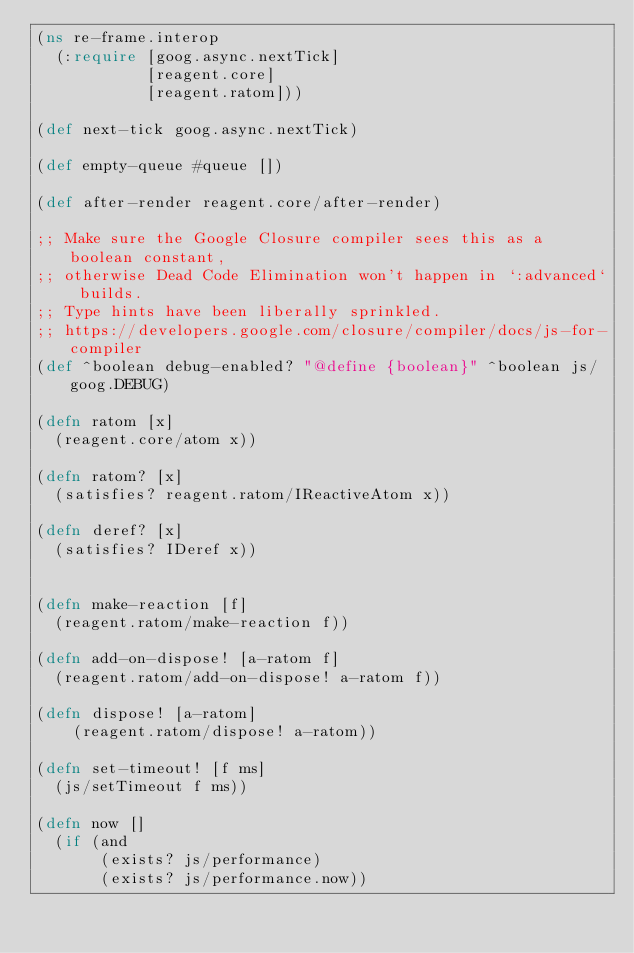Convert code to text. <code><loc_0><loc_0><loc_500><loc_500><_Clojure_>(ns re-frame.interop
  (:require [goog.async.nextTick]
            [reagent.core]
            [reagent.ratom]))

(def next-tick goog.async.nextTick)

(def empty-queue #queue [])

(def after-render reagent.core/after-render)

;; Make sure the Google Closure compiler sees this as a boolean constant,
;; otherwise Dead Code Elimination won't happen in `:advanced` builds.
;; Type hints have been liberally sprinkled.
;; https://developers.google.com/closure/compiler/docs/js-for-compiler
(def ^boolean debug-enabled? "@define {boolean}" ^boolean js/goog.DEBUG)

(defn ratom [x]
  (reagent.core/atom x))

(defn ratom? [x]
  (satisfies? reagent.ratom/IReactiveAtom x))

(defn deref? [x]
  (satisfies? IDeref x))


(defn make-reaction [f]
  (reagent.ratom/make-reaction f))

(defn add-on-dispose! [a-ratom f]
  (reagent.ratom/add-on-dispose! a-ratom f))

(defn dispose! [a-ratom]
	(reagent.ratom/dispose! a-ratom))

(defn set-timeout! [f ms]
  (js/setTimeout f ms))

(defn now []
  (if (and
       (exists? js/performance)
       (exists? js/performance.now))</code> 